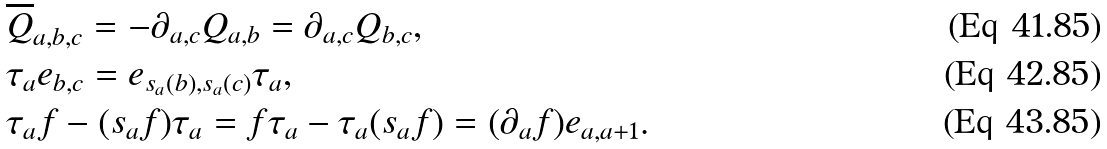<formula> <loc_0><loc_0><loc_500><loc_500>& \overline { Q } _ { a , b , c } = - \partial _ { a , c } Q _ { a , b } = \partial _ { a , c } Q _ { b , c } , \\ & \tau _ { a } e _ { b , c } = e _ { s _ { a } ( b ) , s _ { a } ( c ) } \tau _ { a } , \\ & \tau _ { a } f - ( s _ { a } f ) \tau _ { a } = f \tau _ { a } - \tau _ { a } ( s _ { a } f ) = ( \partial _ { a } f ) e _ { a , a + 1 } .</formula> 